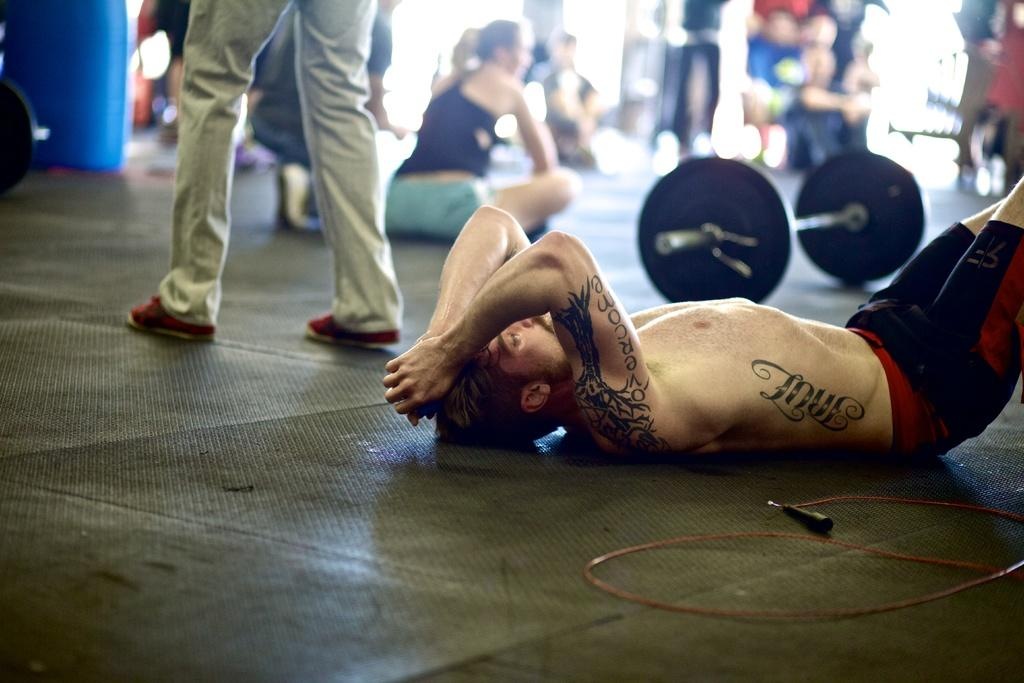What is the main subject of the image? There is a person lying on the ground in the image. What are the other people in the image doing? There are persons sitting and standing in the background of the image. What can be seen in the background of the image? There is gym equipment visible in the background of the image. What type of vessel is being used by the person's grandmother in the image? There is no mention of a grandmother or a vessel in the image. 